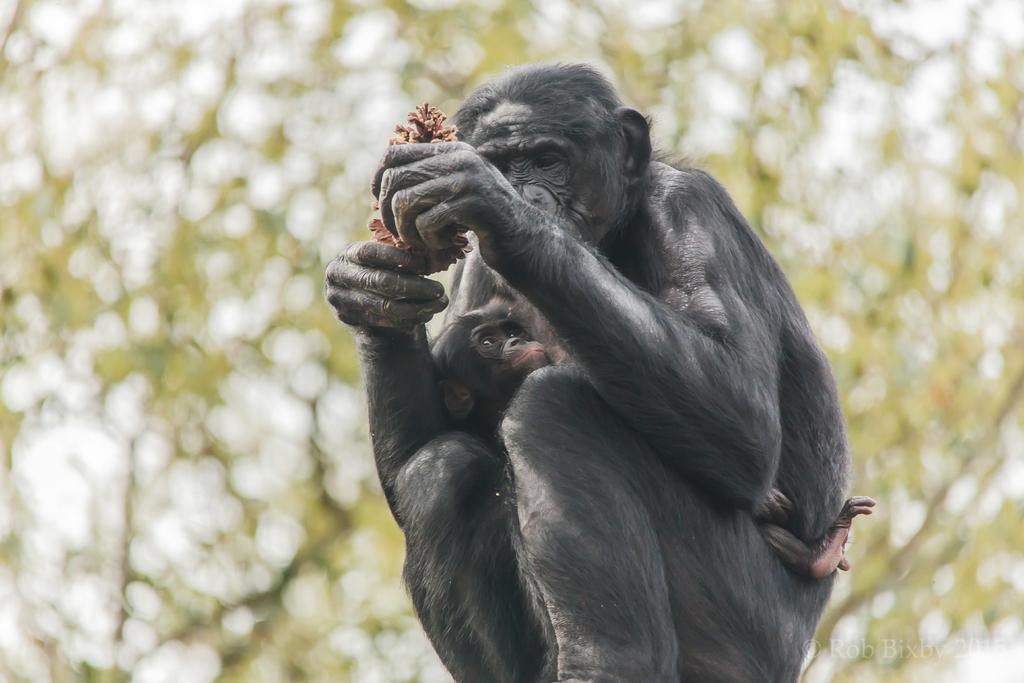In one or two sentences, can you explain what this image depicts? In the picture we can see a monkey sitting and holding some things in the hand and on the monkey we can see a baby monkey sitting on it and in the background we can see a tree. 